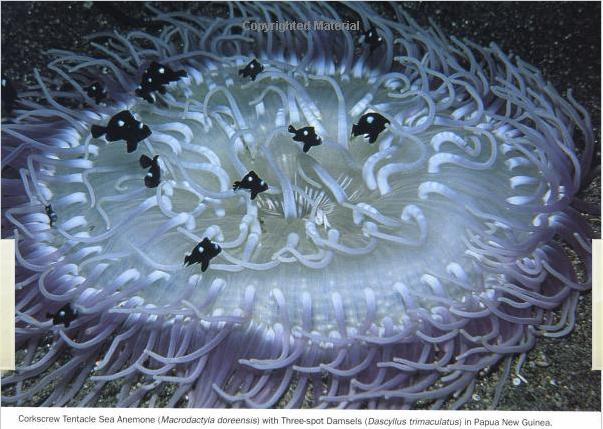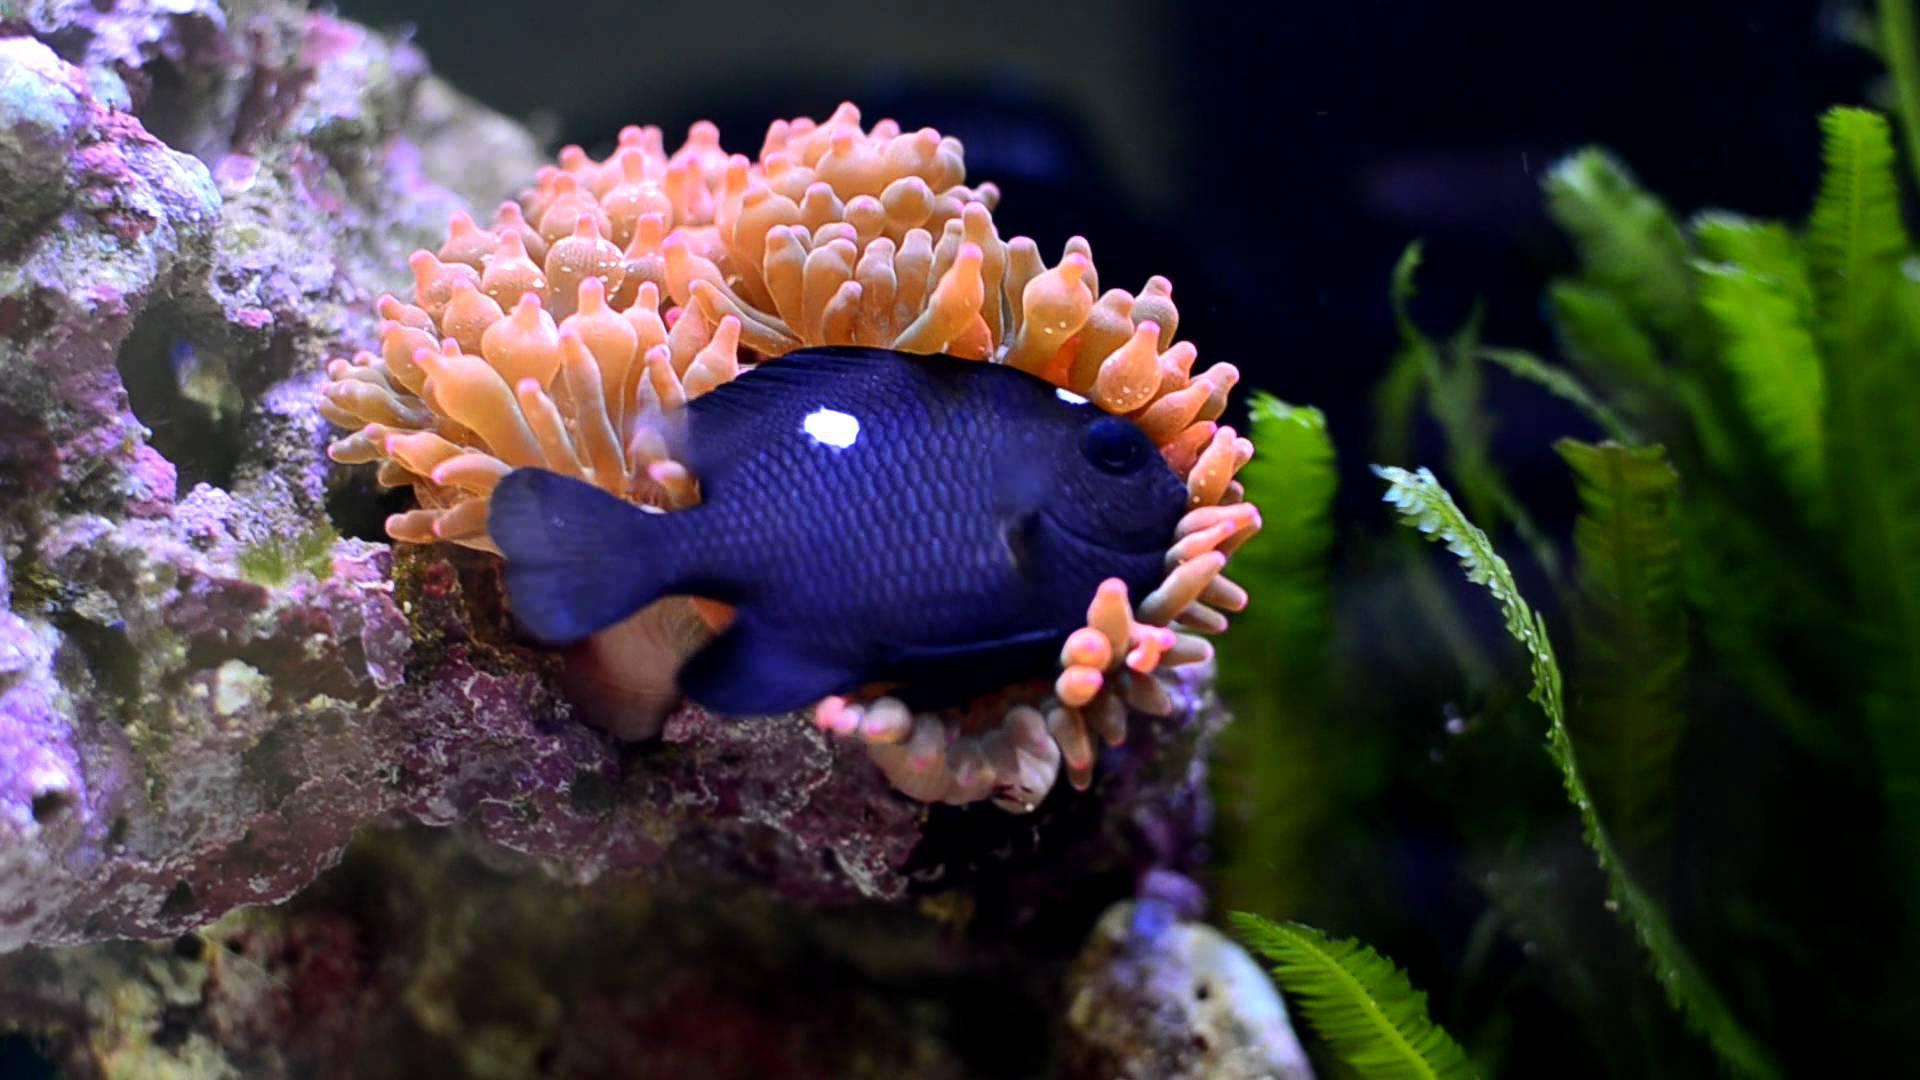The first image is the image on the left, the second image is the image on the right. Analyze the images presented: Is the assertion "There are at least 10 small black and white fish swimming through corral." valid? Answer yes or no. Yes. The first image is the image on the left, the second image is the image on the right. For the images shown, is this caption "One image includes at least ten dark fish with white dots swimming above one large, pale, solid-colored anemone." true? Answer yes or no. Yes. 